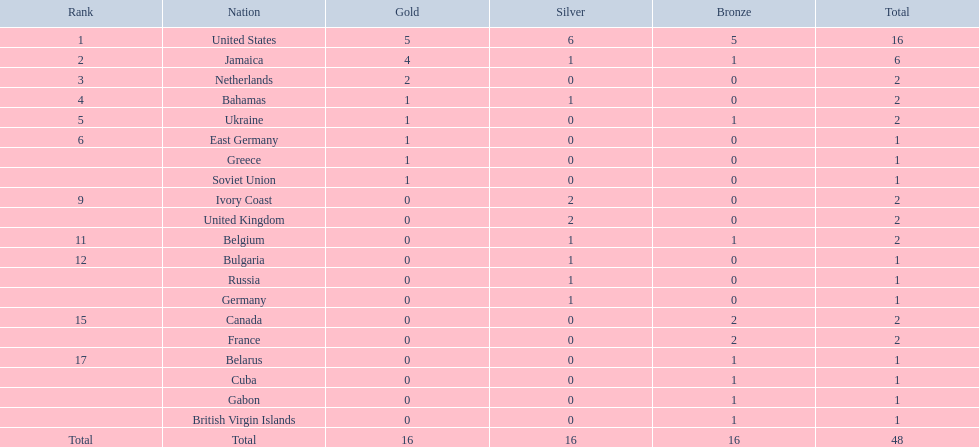Which participating countries were involved? United States, Jamaica, Netherlands, Bahamas, Ukraine, East Germany, Greece, Soviet Union, Ivory Coast, United Kingdom, Belgium, Bulgaria, Russia, Germany, Canada, France, Belarus, Cuba, Gabon, British Virgin Islands. What was the number of gold medals each received? 5, 4, 2, 1, 1, 1, 1, 1, 0, 0, 0, 0, 0, 0, 0, 0, 0, 0, 0, 0. And which country had the most victories? United States. Which nation secured the highest number of medals? United States. How many medals were obtained by the us? 16. After 16, what was the highest number of medals won by any country? 6. Which nation achieved 6 medals? Jamaica. 